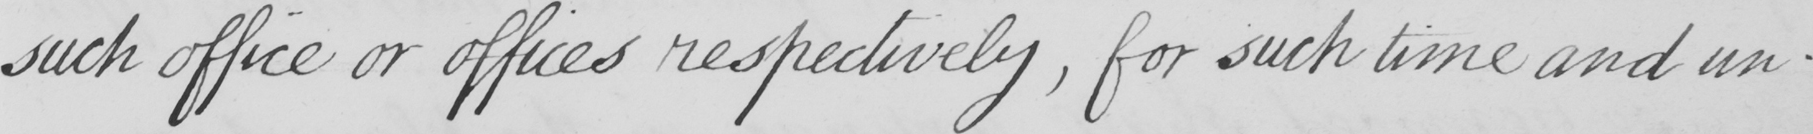Please transcribe the handwritten text in this image. such office or offices respectively  , for such time and un- 